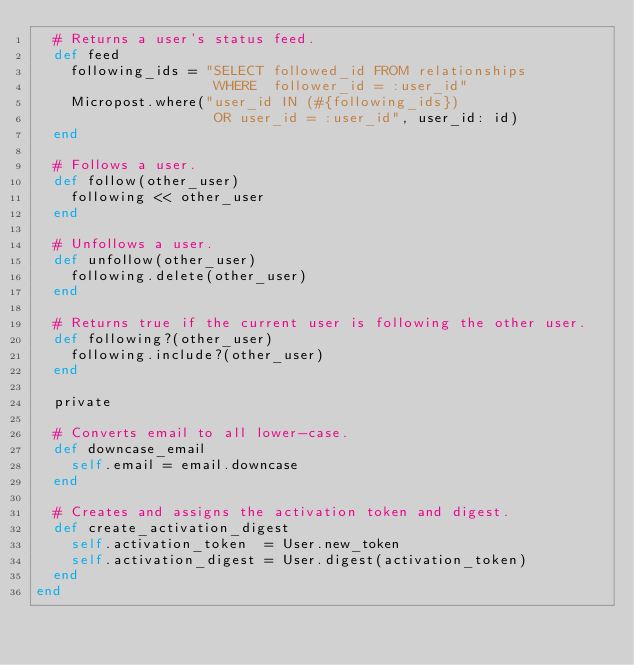<code> <loc_0><loc_0><loc_500><loc_500><_Ruby_>  # Returns a user's status feed.
  def feed
    following_ids = "SELECT followed_id FROM relationships
                     WHERE  follower_id = :user_id"
    Micropost.where("user_id IN (#{following_ids})
                     OR user_id = :user_id", user_id: id)
  end

  # Follows a user.
  def follow(other_user)
    following << other_user
  end

  # Unfollows a user.
  def unfollow(other_user)
    following.delete(other_user)
  end

  # Returns true if the current user is following the other user.
  def following?(other_user)
    following.include?(other_user)
  end

  private

  # Converts email to all lower-case.
  def downcase_email
    self.email = email.downcase
  end

  # Creates and assigns the activation token and digest.
  def create_activation_digest
    self.activation_token  = User.new_token
    self.activation_digest = User.digest(activation_token)
  end
end
</code> 